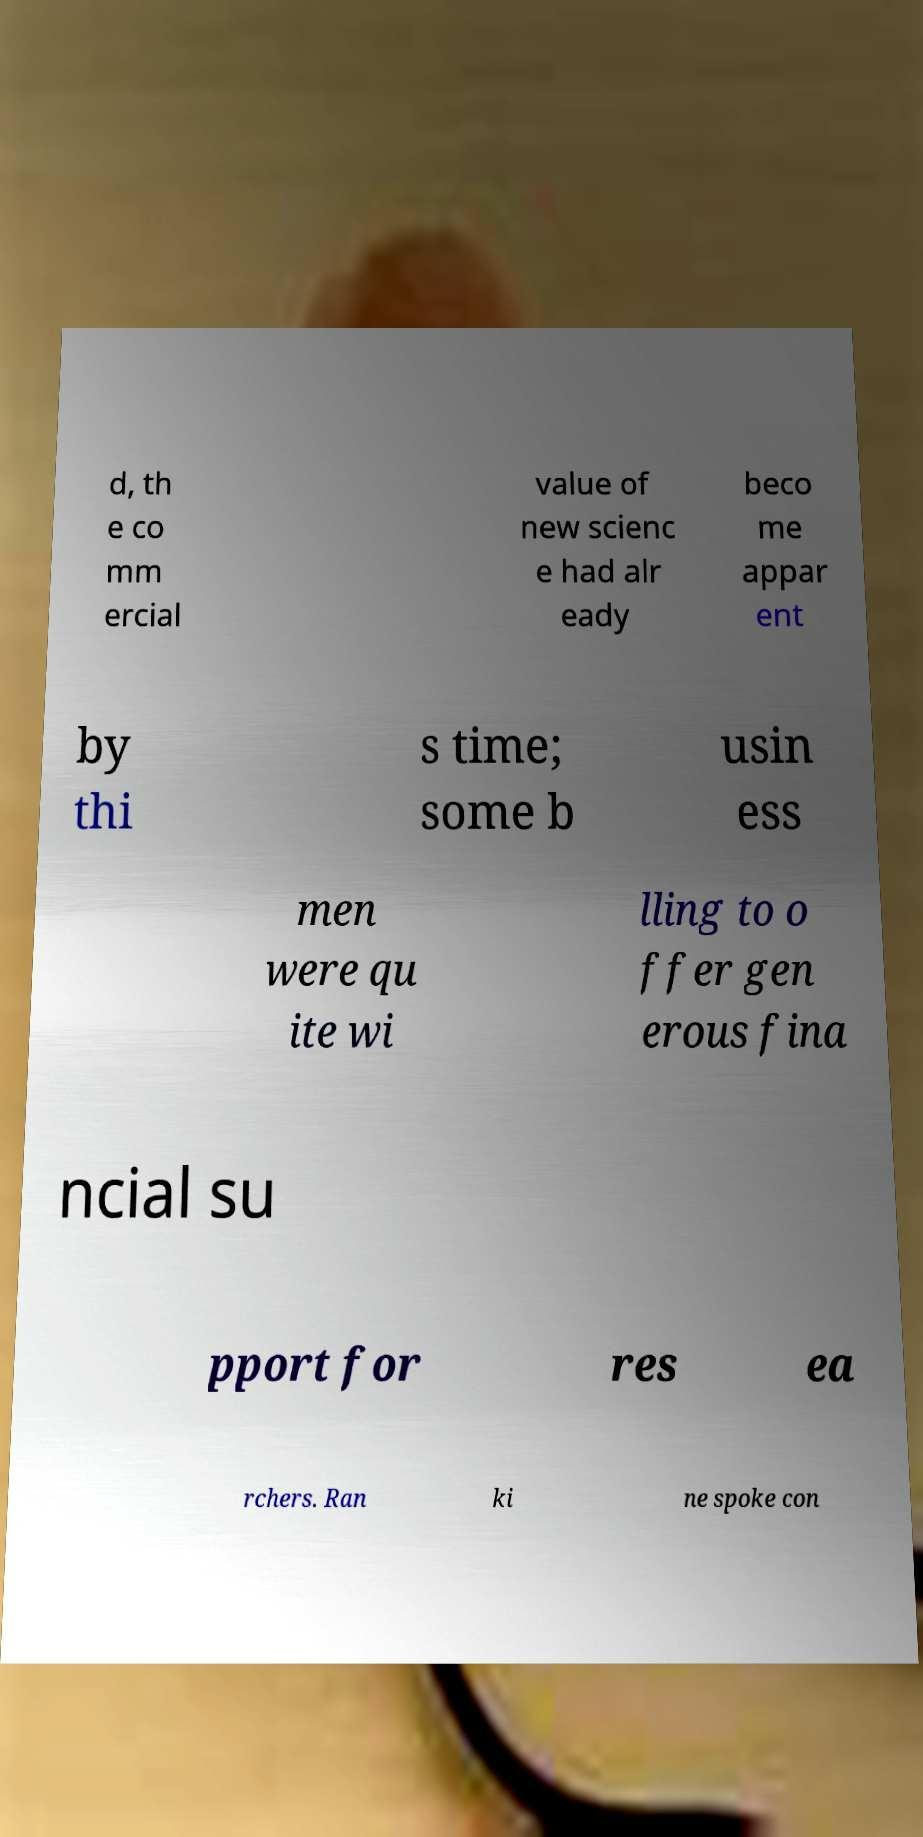Can you accurately transcribe the text from the provided image for me? d, th e co mm ercial value of new scienc e had alr eady beco me appar ent by thi s time; some b usin ess men were qu ite wi lling to o ffer gen erous fina ncial su pport for res ea rchers. Ran ki ne spoke con 